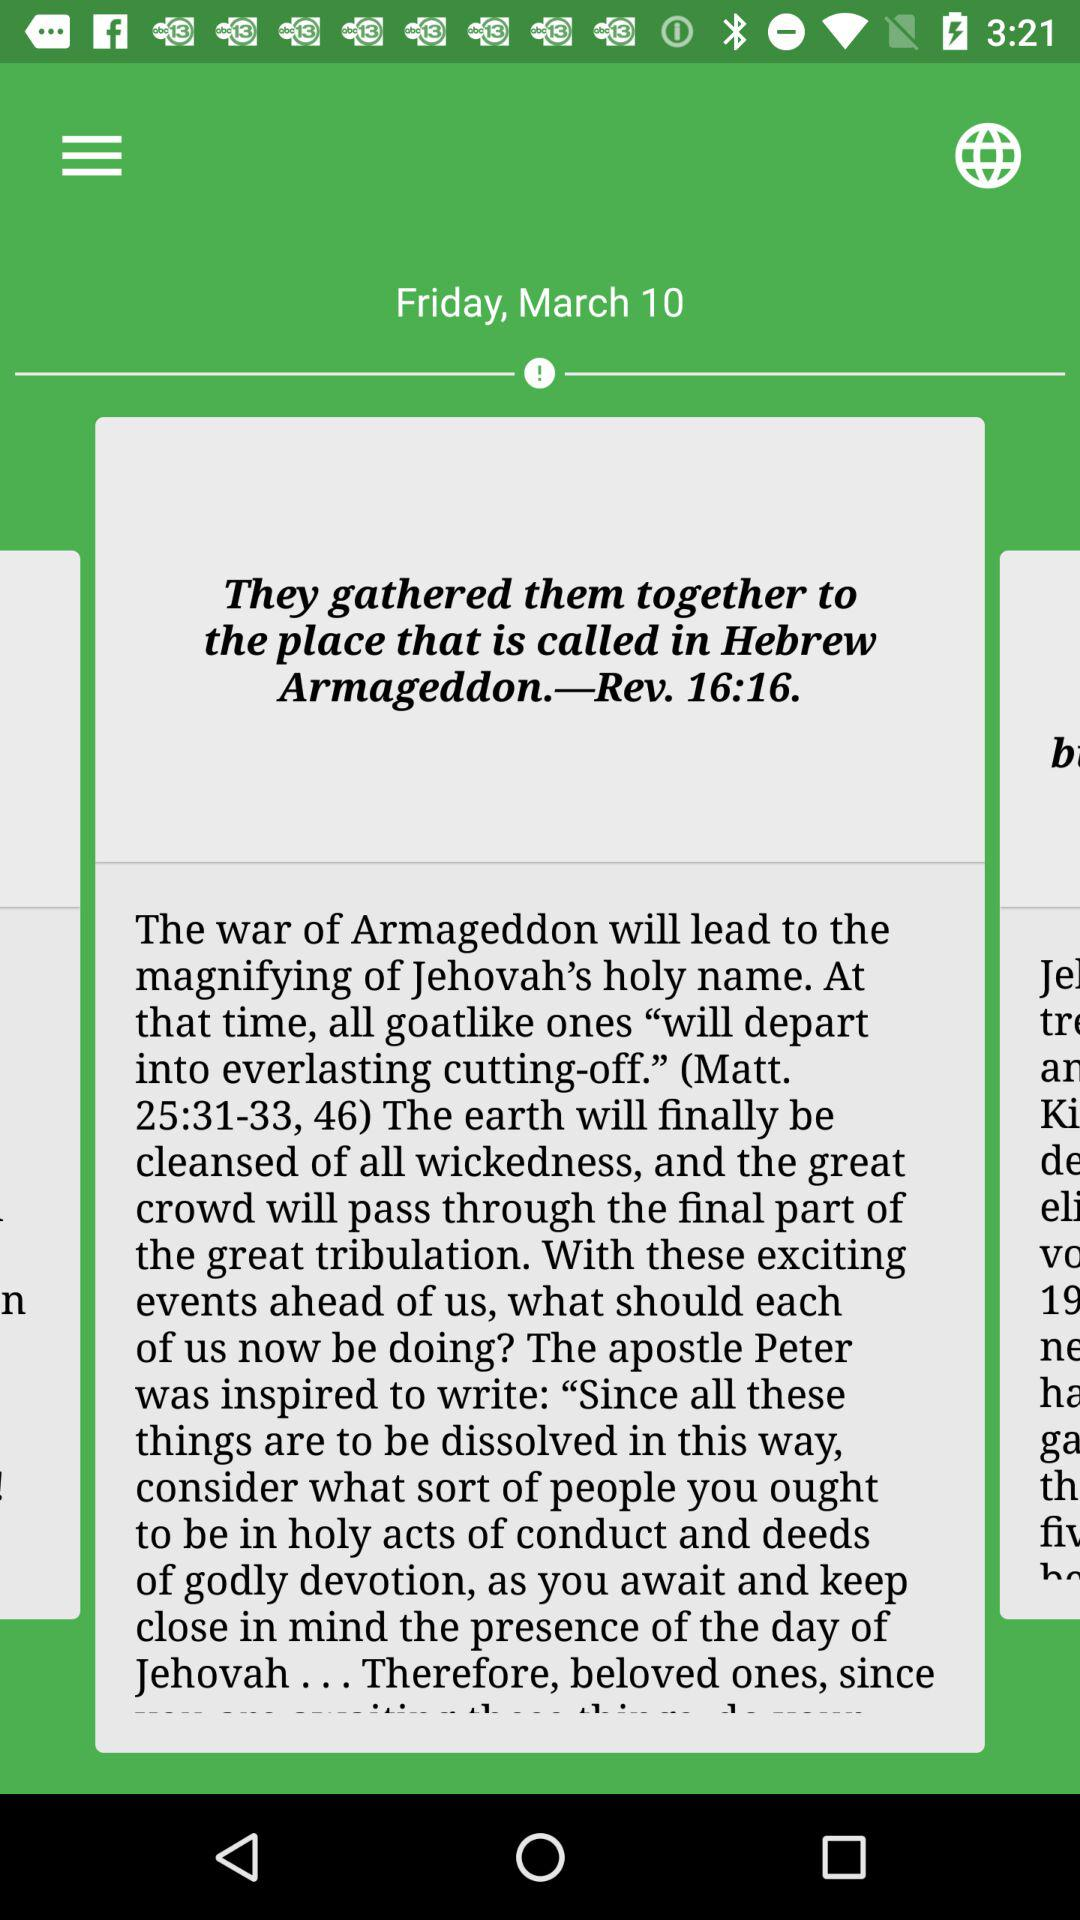What is the date? The date is Friday, March 10. 